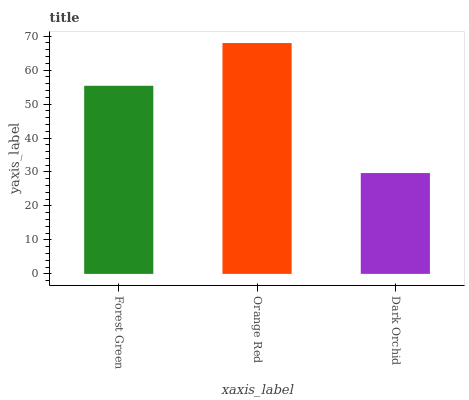Is Dark Orchid the minimum?
Answer yes or no. Yes. Is Orange Red the maximum?
Answer yes or no. Yes. Is Orange Red the minimum?
Answer yes or no. No. Is Dark Orchid the maximum?
Answer yes or no. No. Is Orange Red greater than Dark Orchid?
Answer yes or no. Yes. Is Dark Orchid less than Orange Red?
Answer yes or no. Yes. Is Dark Orchid greater than Orange Red?
Answer yes or no. No. Is Orange Red less than Dark Orchid?
Answer yes or no. No. Is Forest Green the high median?
Answer yes or no. Yes. Is Forest Green the low median?
Answer yes or no. Yes. Is Orange Red the high median?
Answer yes or no. No. Is Orange Red the low median?
Answer yes or no. No. 